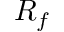<formula> <loc_0><loc_0><loc_500><loc_500>R _ { f }</formula> 